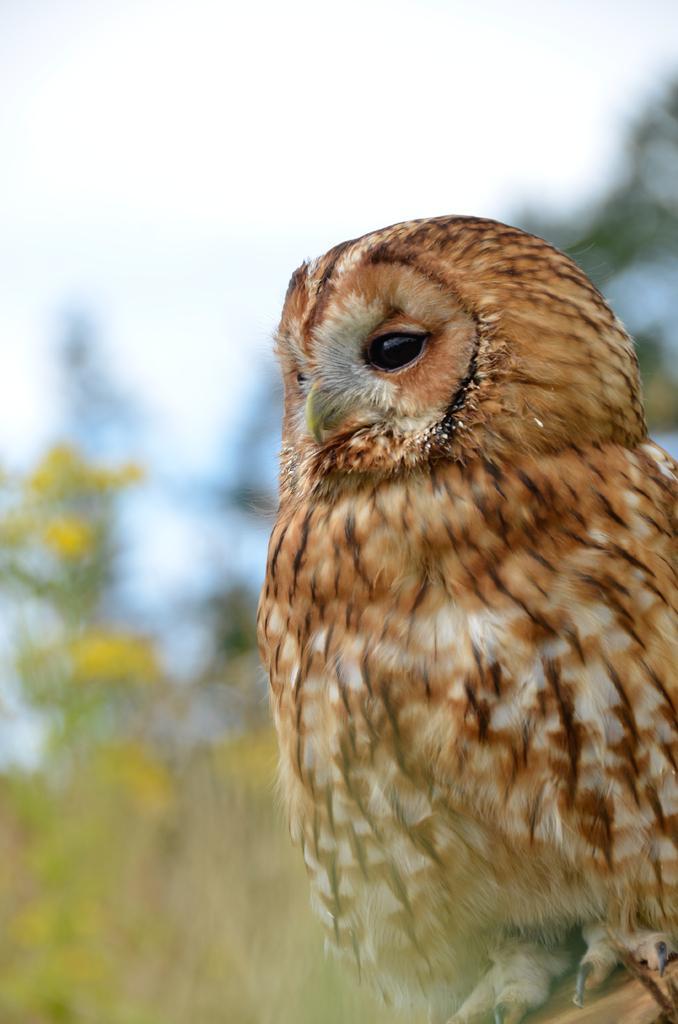Could you give a brief overview of what you see in this image? In this image I can see the bird which is in brown color. It is standing on the brown color surface. To the left there are some yellow color flowers to the plant. In the back I can see the plants and the sky. But it is blurry. 